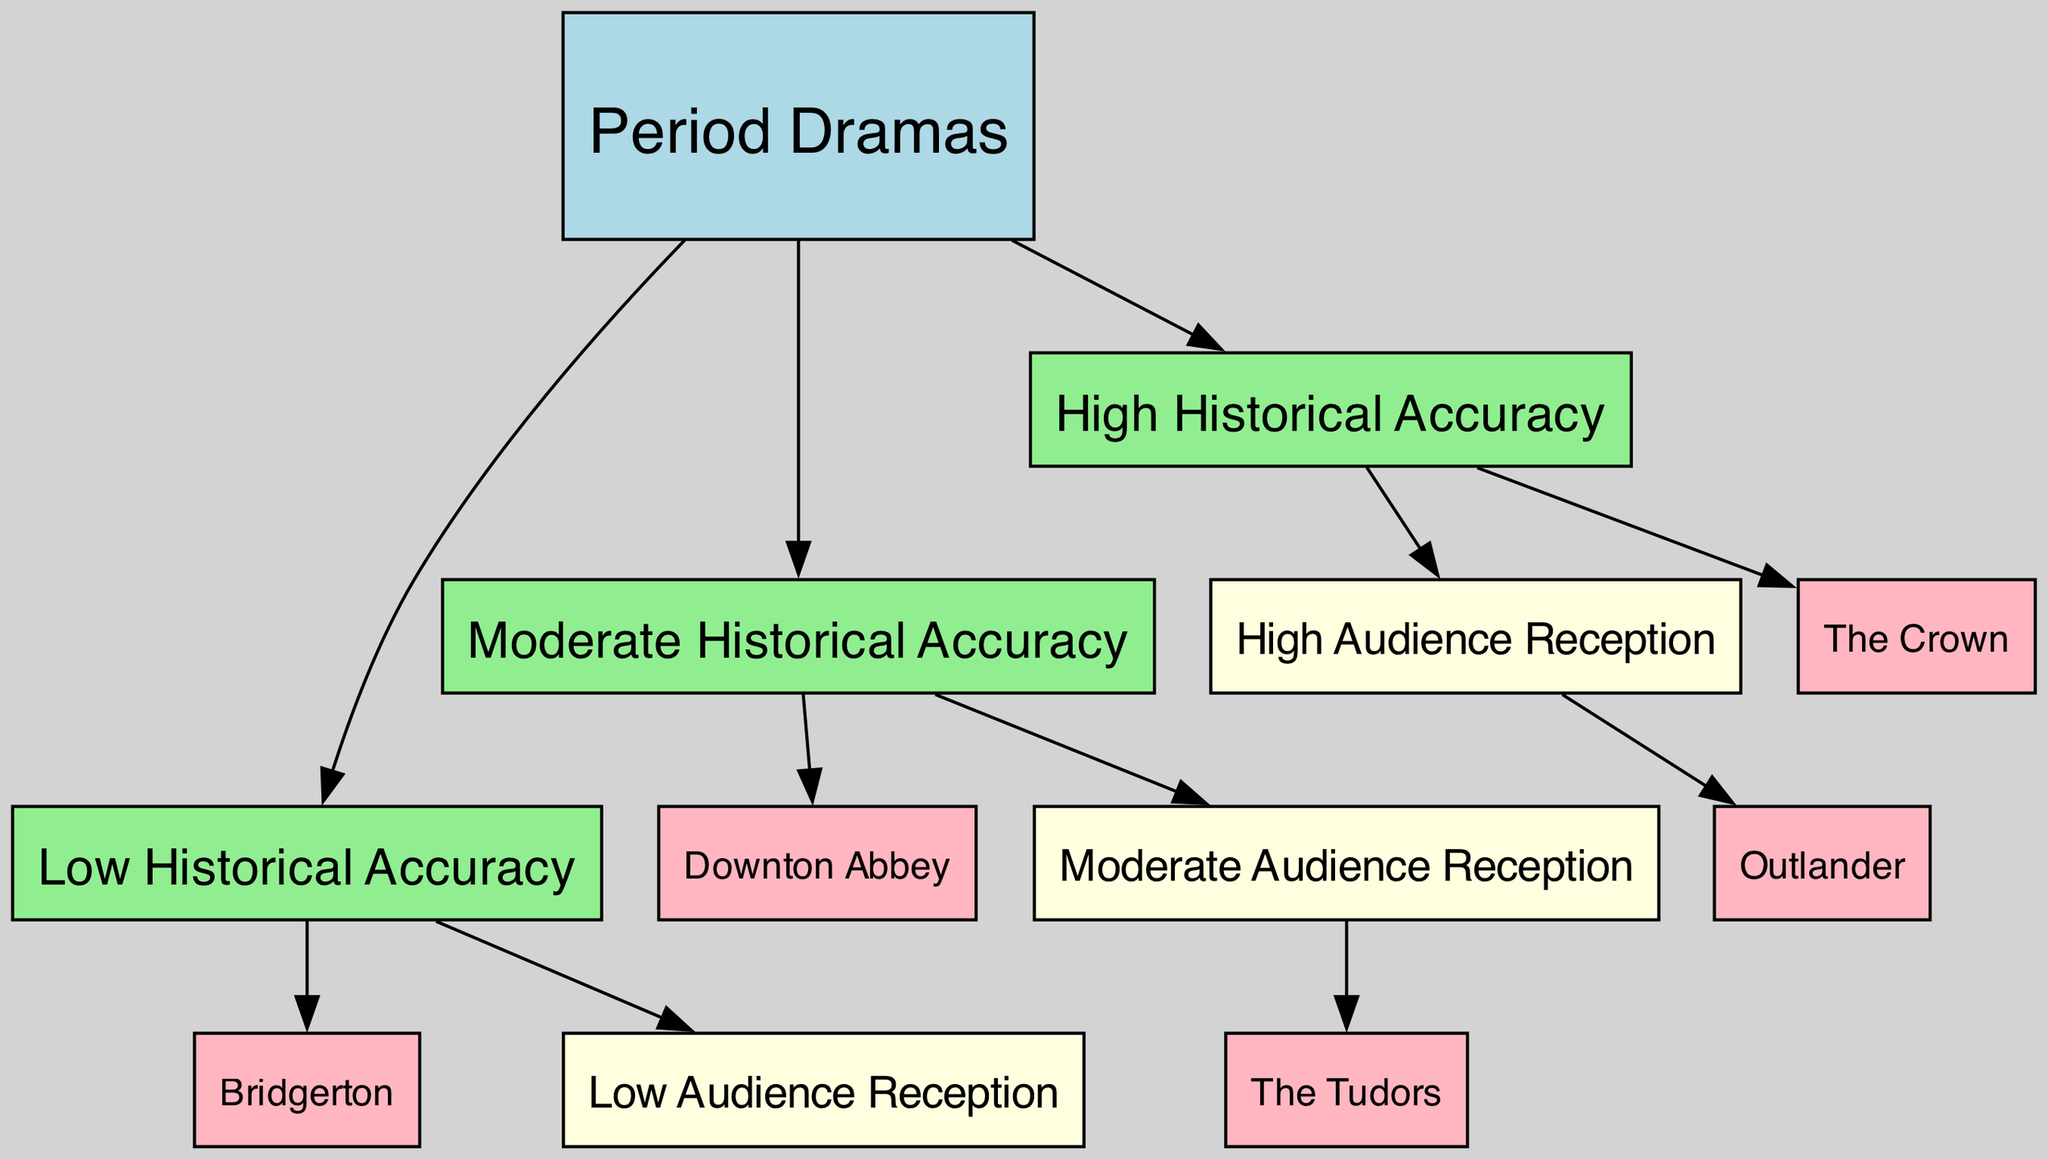What is the total number of nodes in the diagram? The diagram includes nodes that represent "Period Dramas," "High Historical Accuracy," "Moderate Historical Accuracy," "Low Historical Accuracy," "High Audience Reception," "Moderate Audience Reception," "Low Audience Reception," and specific titles like "The Crown," "Downton Abbey," "Bridgerton," "Outlander," and "The Tudors." Adding these gives a total of 12 nodes.
Answer: 12 Which period drama has High Historical Accuracy and High Audience Reception? The edges in the diagram connect "High Historical Accuracy" to "The Crown," and "High Audience Reception" also connects to "The Crown." Thus, "The Crown" is the period drama that fits both categories.
Answer: The Crown How many period dramas have Low Historical Accuracy? The edges illustrated in the diagram show that "Low Historical Accuracy" connects to "Bridgerton." As a result, there is only 1 period drama in this category.
Answer: 1 Which period drama is associated with Moderate Audience Reception? The diagram shows an edge from "Moderate Audience Reception" to "The Tudors," indicating that "The Tudors" is the period drama categorized as having moderate audience reception.
Answer: The Tudors What type of relationship is represented between High Historical Accuracy and High Audience Reception? The edges from "High Historical Accuracy" to "High Audience Reception," and from "High Historical Accuracy" to "The Crown" indicate that there is a direct connection. This relationship suggests that higher historical accuracy correlates with better audience reception.
Answer: Direct connection Which period drama connects to both Low Audience Reception and Low Historical Accuracy? The edge relationships indicate that "Bridgerton" is linked to both "Low Audience Reception" and "Low Historical Accuracy," meaning it fits those classifications.
Answer: Bridgerton What categories are connected to Downton Abbey? "Downton Abbey" is connected to "Moderate Audience Reception," indicated by the edge flowing from "Moderate Audience Reception" to "Downton Abbey." It is also connected to "Moderate Historical Accuracy," which is represented by the flow from "Moderate Historical Accuracy" to "Downton Abbey."
Answer: Moderate Historical Accuracy; Moderate Audience Reception Which node has the most direct connections? "Period Dramas" has edges going to "High Historical Accuracy," "Moderate Historical Accuracy," and "Low Historical Accuracy," meaning it directly connects to three different nodes, making it the node with the most connections in the diagram.
Answer: Period Dramas 